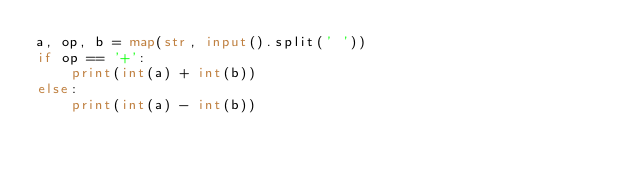<code> <loc_0><loc_0><loc_500><loc_500><_Python_>a, op, b = map(str, input().split(' '))
if op == '+':
    print(int(a) + int(b))
else:
    print(int(a) - int(b))</code> 